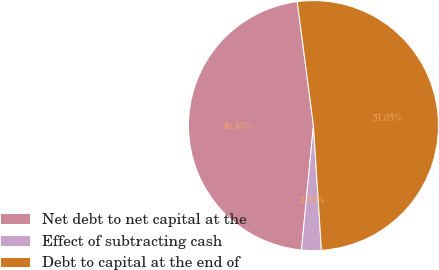<chart> <loc_0><loc_0><loc_500><loc_500><pie_chart><fcel>Net debt to net capital at the<fcel>Effect of subtracting cash<fcel>Debt to capital at the end of<nl><fcel>46.4%<fcel>2.55%<fcel>51.05%<nl></chart> 